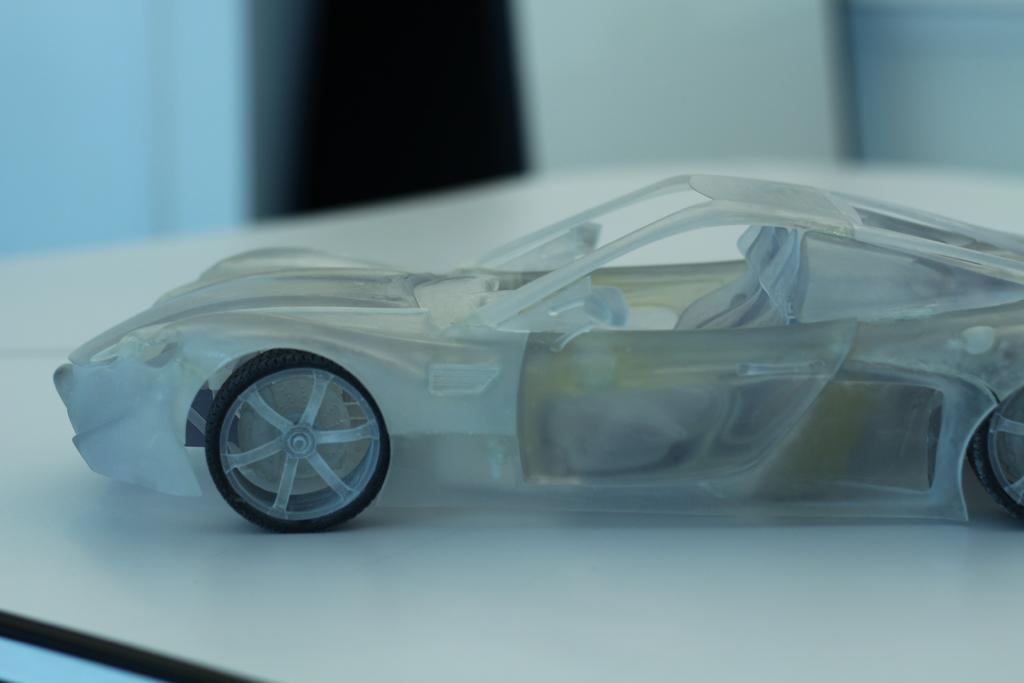Describe this image in one or two sentences. In this image, we can see a toy car on the table. In the background, image is blurred. 